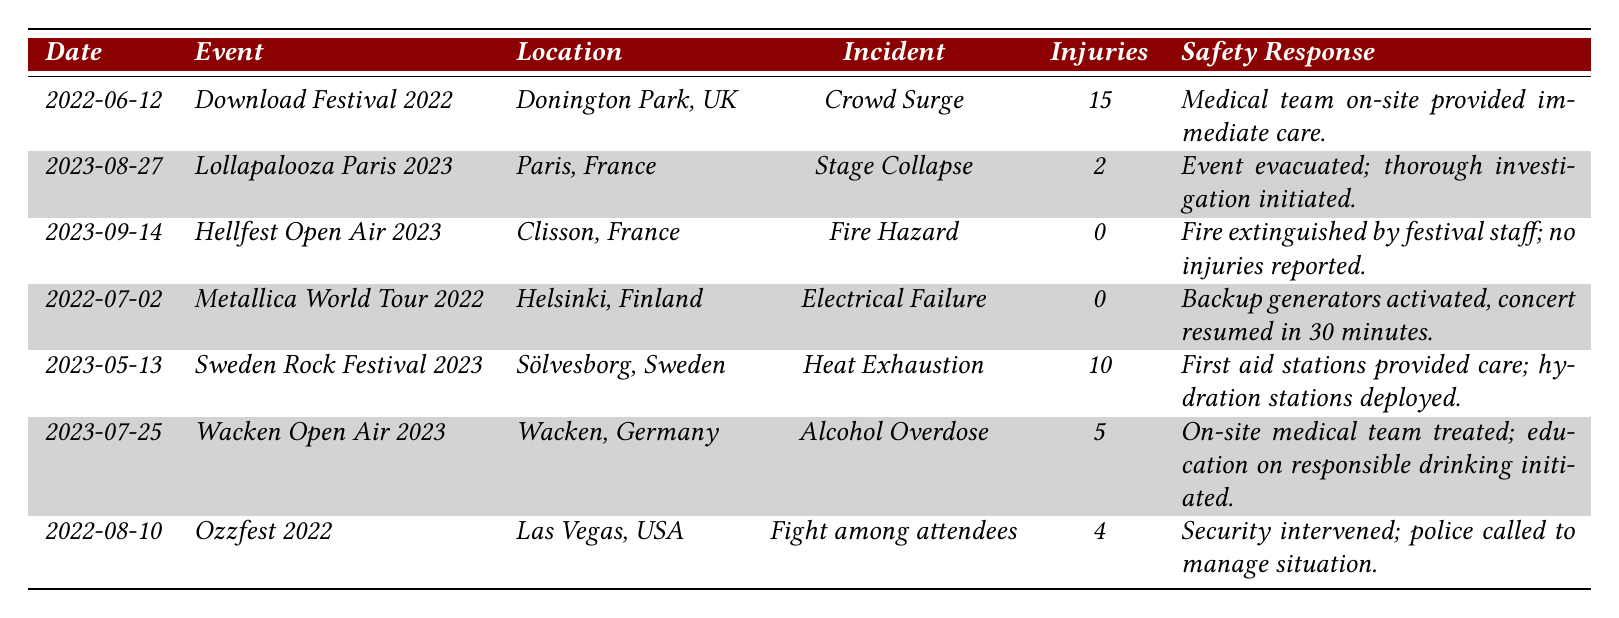What incident occurred on June 12, 2022? The table shows that on June 12, 2022, at the Download Festival 2022, a Crowd Surge incident occurred.
Answer: Crowd Surge How many reported injuries were there at the Sweden Rock Festival 2023? According to the table, the Sweden Rock Festival 2023 reported 10 injuries due to Heat Exhaustion.
Answer: 10 Was there any incident that resulted in zero reported injuries? Yes, the table indicates that there were incidents with zero reported injuries, specifically the Fire Hazard at Hellfest Open Air 2023 and the Electrical Failure during the Metallica World Tour 2022.
Answer: Yes What is the total number of injuries reported across all incidents in the table? To find the total, we sum the reported injuries: 15 (Crowd Surge) + 2 (Stage Collapse) + 0 (Fire Hazard) + 0 (Electrical Failure) + 10 (Heat Exhaustion) + 5 (Alcohol Overdose) + 4 (Fight among attendees) = 36.
Answer: 36 Which incident had the highest number of injuries and how many were reported? The incident with the highest number of reported injuries was the Crowd Surge at Download Festival 2022, which reported 15 injuries.
Answer: Crowd Surge, 15 At which event did the safety response involve an evacuation? The Lollapalooza Paris 2023 incident had the safety response of evacuation due to a Stage Collapse.
Answer: Lollapalooza Paris 2023 How many incidents were related to medical issues, such as heat exhaustion and alcohol overdose? There are 2 incidents that relate to medical issues: 1 for Heat Exhaustion at Sweden Rock Festival 2023 and 1 for Alcohol Overdose at Wacken Open Air 2023, totaling 2 incidents.
Answer: 2 What was the common safety response for incidents that involved injuries? The table indicates that safety responses to incidents with reported injuries often included immediate care from medical teams, as seen in the Crowd Surge and Alcohol Overdose incidents.
Answer: Immediate care from medical teams Which festival had an incident with a fire hazard and how was it managed? The Hellfest Open Air 2023 had an incident categorized as a Fire Hazard, and it was managed by extinguishing the fire by festival staff with no injuries reported.
Answer: Hellfest Open Air 2023, fire extinguished by staff How many events had incidents classified as structural failures? There were two events classified as structural failures: the Stage Collapse at Lollapalooza Paris 2023 and the Electrical Failure during the Metallica World Tour 2022.
Answer: 2 